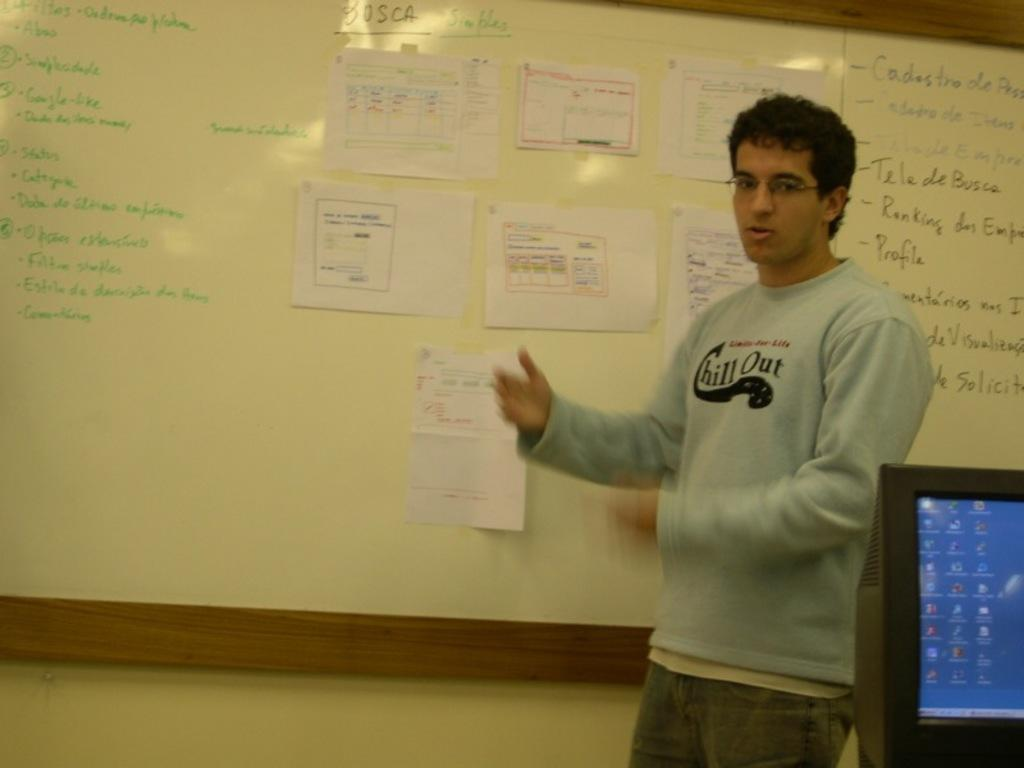<image>
Provide a brief description of the given image. Man standing in front of a board which says "OSCA" on it. 